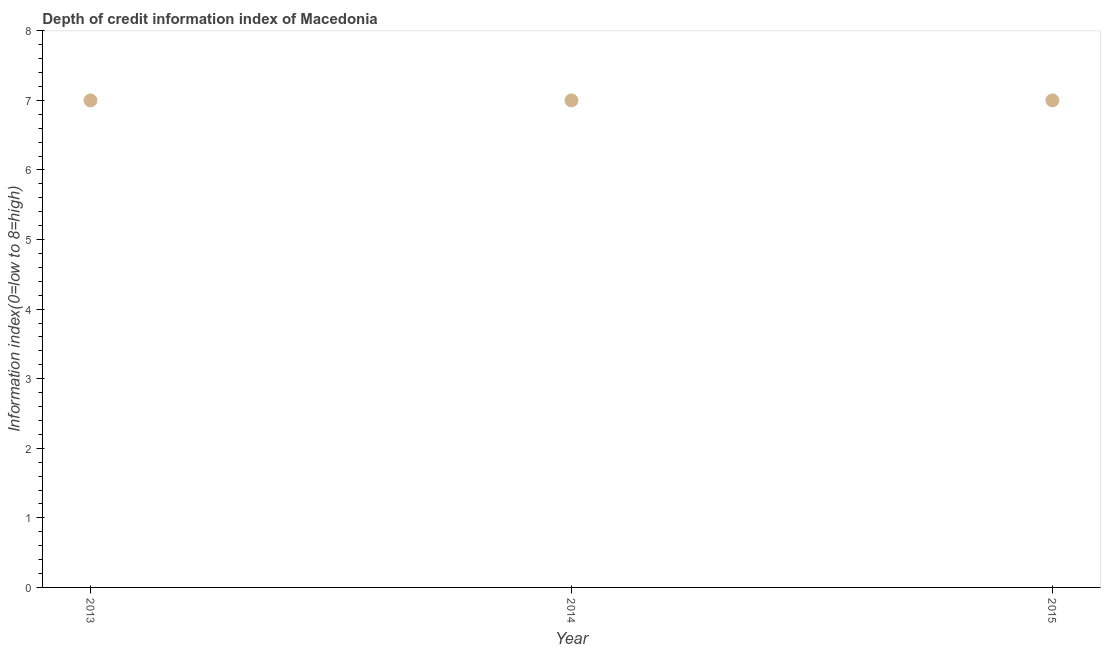What is the depth of credit information index in 2013?
Your answer should be very brief. 7. Across all years, what is the maximum depth of credit information index?
Your response must be concise. 7. Across all years, what is the minimum depth of credit information index?
Provide a succinct answer. 7. What is the sum of the depth of credit information index?
Give a very brief answer. 21. Is the depth of credit information index in 2013 less than that in 2014?
Make the answer very short. No. Does the depth of credit information index monotonically increase over the years?
Provide a short and direct response. No. What is the difference between two consecutive major ticks on the Y-axis?
Provide a succinct answer. 1. Does the graph contain any zero values?
Ensure brevity in your answer.  No. What is the title of the graph?
Provide a succinct answer. Depth of credit information index of Macedonia. What is the label or title of the X-axis?
Keep it short and to the point. Year. What is the label or title of the Y-axis?
Make the answer very short. Information index(0=low to 8=high). What is the Information index(0=low to 8=high) in 2013?
Ensure brevity in your answer.  7. What is the difference between the Information index(0=low to 8=high) in 2013 and 2014?
Keep it short and to the point. 0. What is the difference between the Information index(0=low to 8=high) in 2013 and 2015?
Offer a terse response. 0. What is the ratio of the Information index(0=low to 8=high) in 2013 to that in 2014?
Your answer should be compact. 1. 